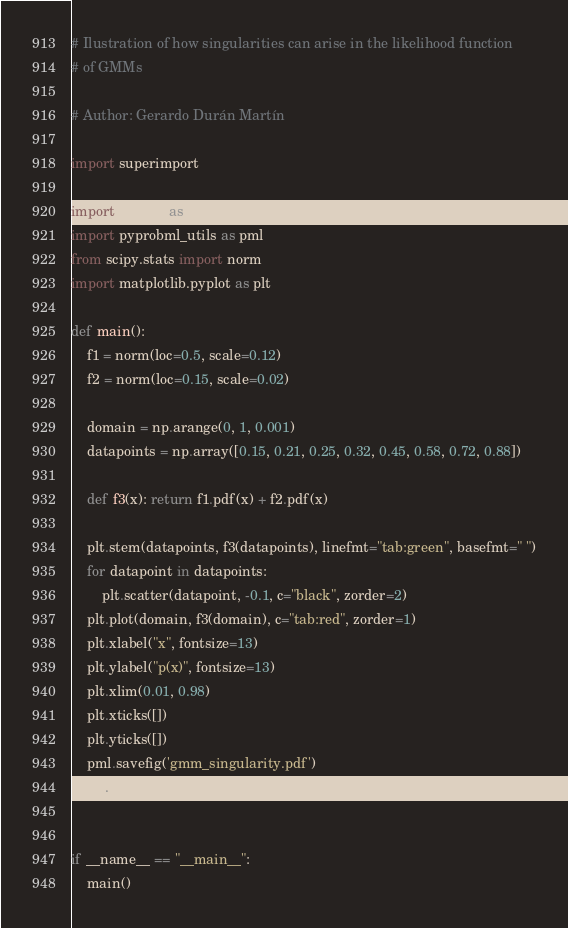<code> <loc_0><loc_0><loc_500><loc_500><_Python_># Ilustration of how singularities can arise in the likelihood function
# of GMMs

# Author: Gerardo Durán Martín

import superimport

import numpy as np
import pyprobml_utils as pml
from scipy.stats import norm
import matplotlib.pyplot as plt

def main():
    f1 = norm(loc=0.5, scale=0.12)
    f2 = norm(loc=0.15, scale=0.02)

    domain = np.arange(0, 1, 0.001)
    datapoints = np.array([0.15, 0.21, 0.25, 0.32, 0.45, 0.58, 0.72, 0.88])

    def f3(x): return f1.pdf(x) + f2.pdf(x)

    plt.stem(datapoints, f3(datapoints), linefmt="tab:green", basefmt=" ")
    for datapoint in datapoints:
        plt.scatter(datapoint, -0.1, c="black", zorder=2)
    plt.plot(domain, f3(domain), c="tab:red", zorder=1)
    plt.xlabel("x", fontsize=13)
    plt.ylabel("p(x)", fontsize=13)
    plt.xlim(0.01, 0.98)
    plt.xticks([])
    plt.yticks([])
    pml.savefig('gmm_singularity.pdf')
    plt.show()


if __name__ == "__main__":
    main()
</code> 